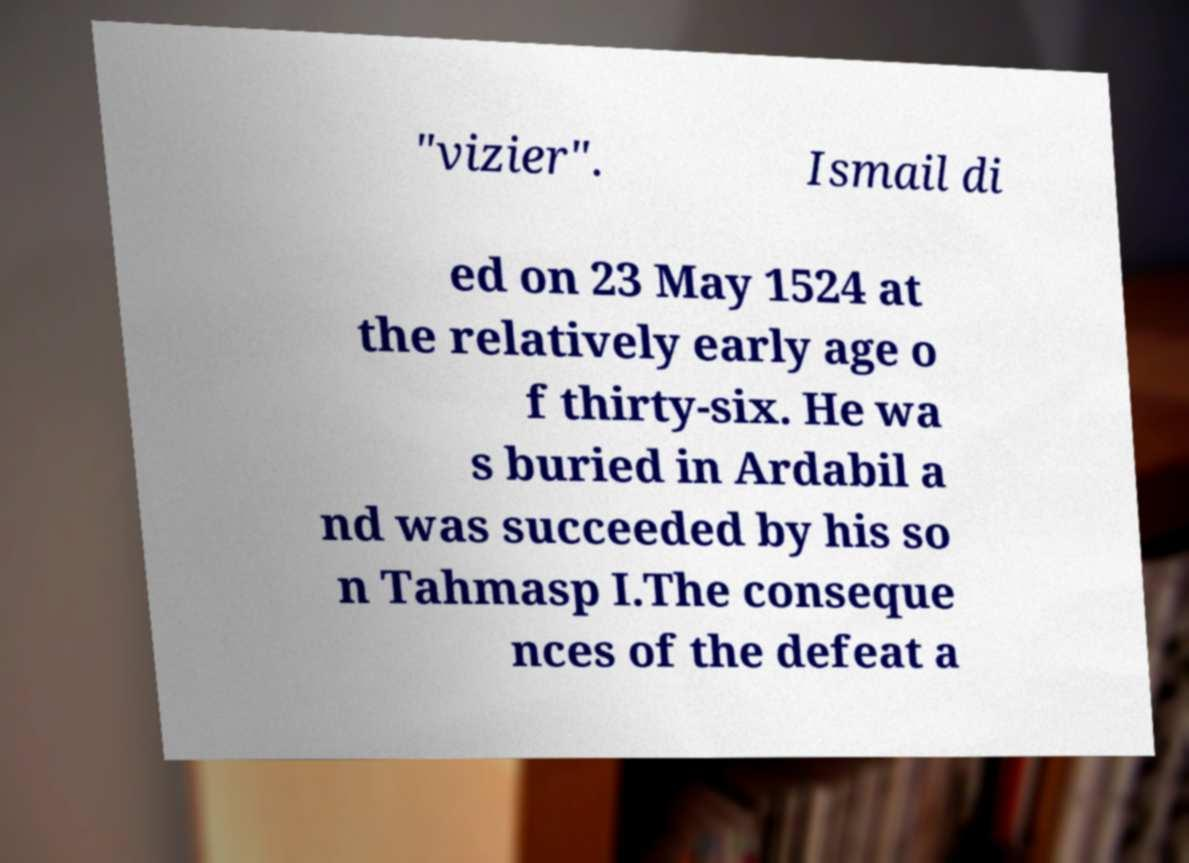Could you assist in decoding the text presented in this image and type it out clearly? "vizier". Ismail di ed on 23 May 1524 at the relatively early age o f thirty-six. He wa s buried in Ardabil a nd was succeeded by his so n Tahmasp I.The conseque nces of the defeat a 